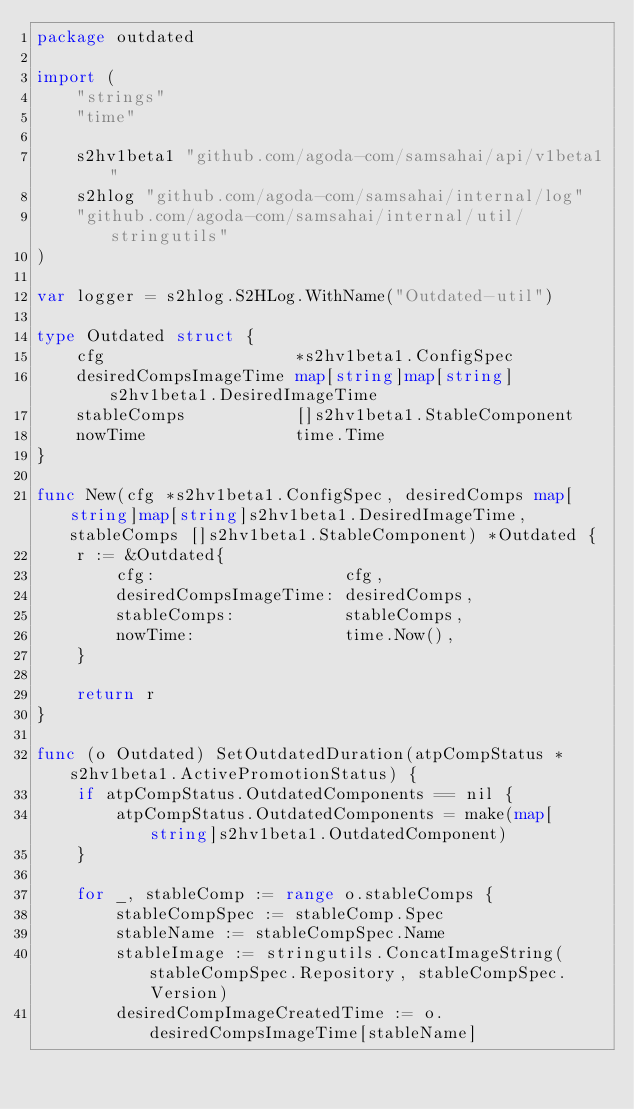Convert code to text. <code><loc_0><loc_0><loc_500><loc_500><_Go_>package outdated

import (
	"strings"
	"time"

	s2hv1beta1 "github.com/agoda-com/samsahai/api/v1beta1"
	s2hlog "github.com/agoda-com/samsahai/internal/log"
	"github.com/agoda-com/samsahai/internal/util/stringutils"
)

var logger = s2hlog.S2HLog.WithName("Outdated-util")

type Outdated struct {
	cfg                   *s2hv1beta1.ConfigSpec
	desiredCompsImageTime map[string]map[string]s2hv1beta1.DesiredImageTime
	stableComps           []s2hv1beta1.StableComponent
	nowTime               time.Time
}

func New(cfg *s2hv1beta1.ConfigSpec, desiredComps map[string]map[string]s2hv1beta1.DesiredImageTime, stableComps []s2hv1beta1.StableComponent) *Outdated {
	r := &Outdated{
		cfg:                   cfg,
		desiredCompsImageTime: desiredComps,
		stableComps:           stableComps,
		nowTime:               time.Now(),
	}

	return r
}

func (o Outdated) SetOutdatedDuration(atpCompStatus *s2hv1beta1.ActivePromotionStatus) {
	if atpCompStatus.OutdatedComponents == nil {
		atpCompStatus.OutdatedComponents = make(map[string]s2hv1beta1.OutdatedComponent)
	}

	for _, stableComp := range o.stableComps {
		stableCompSpec := stableComp.Spec
		stableName := stableCompSpec.Name
		stableImage := stringutils.ConcatImageString(stableCompSpec.Repository, stableCompSpec.Version)
		desiredCompImageCreatedTime := o.desiredCompsImageTime[stableName]</code> 